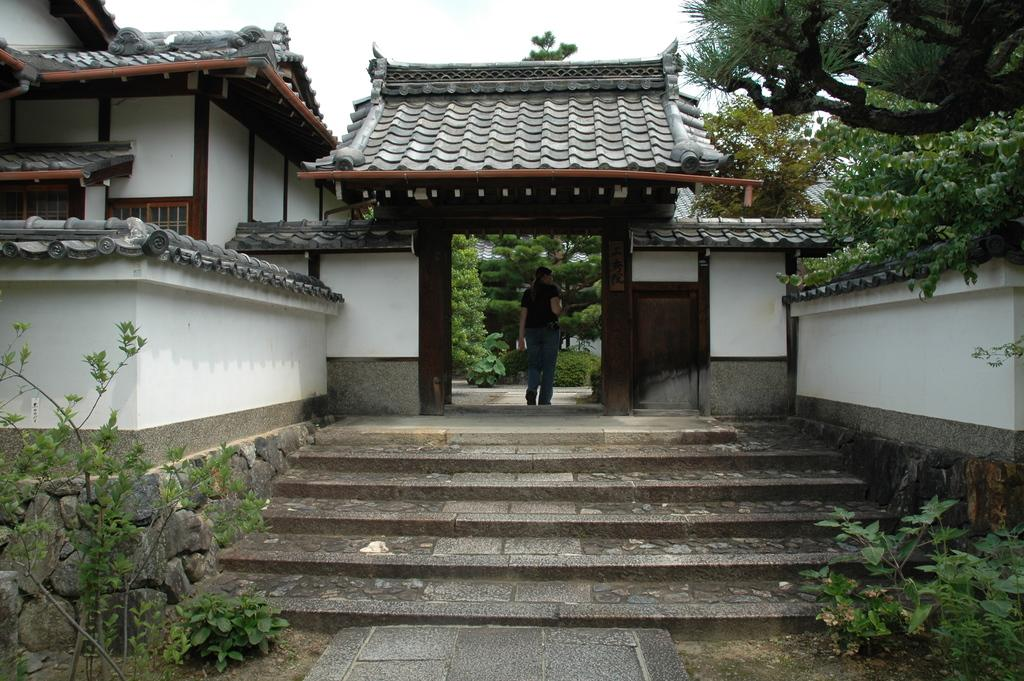What is the woman in the image doing? The woman is walking in the image. What can be seen at the bottom of the image? There are stairs, a footpath, plants, and a stone wall at the bottom of the image. What is visible in the background of the image? There is a house, glass windows, a roof, trees, and the sky visible in the background of the image. What statement does the stranger make to the woman in the image? There is no stranger present in the image, so it is not possible to determine what statement they might make to the woman. 